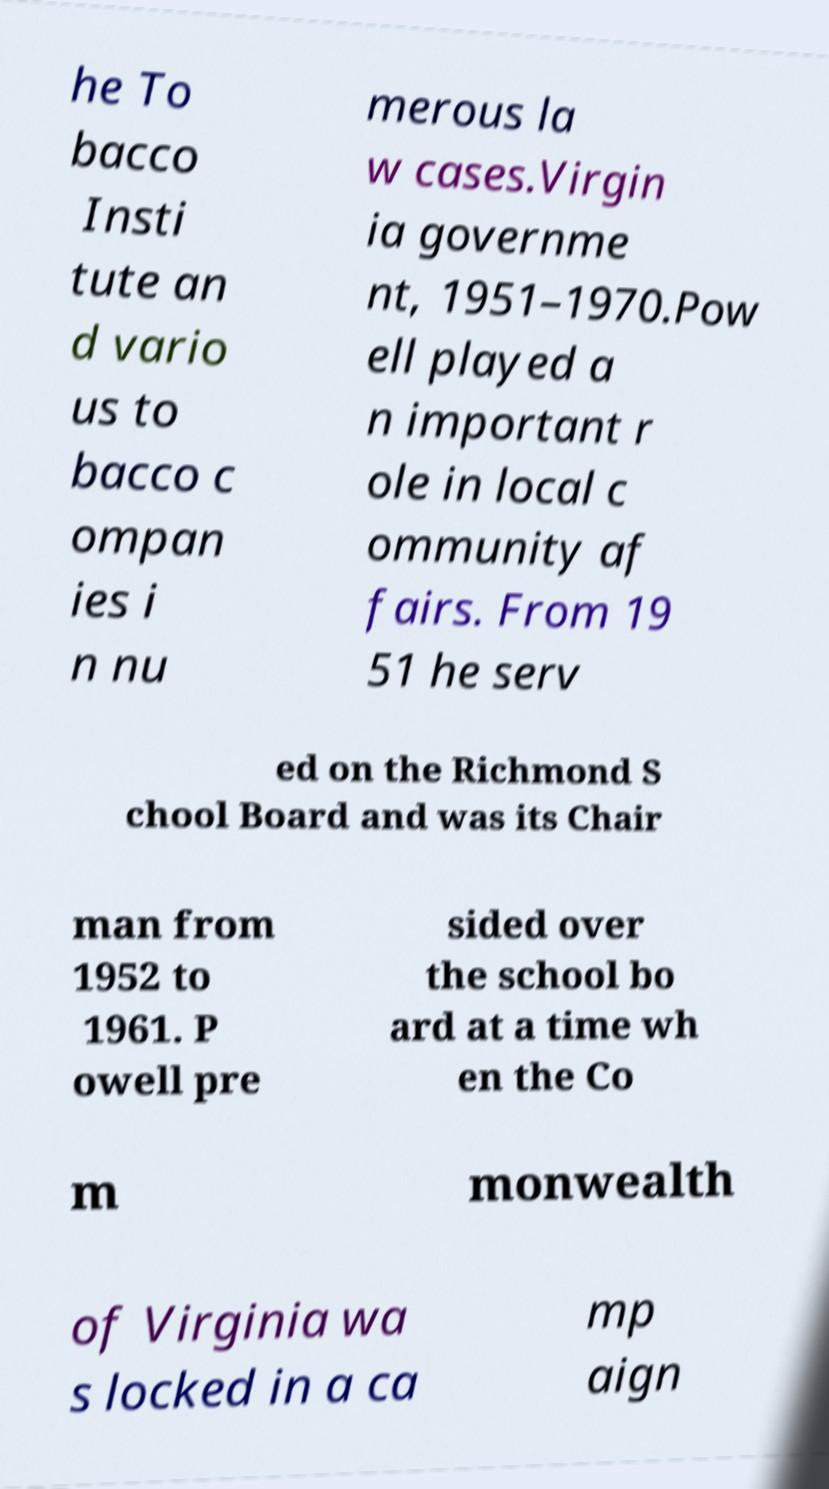Can you accurately transcribe the text from the provided image for me? he To bacco Insti tute an d vario us to bacco c ompan ies i n nu merous la w cases.Virgin ia governme nt, 1951–1970.Pow ell played a n important r ole in local c ommunity af fairs. From 19 51 he serv ed on the Richmond S chool Board and was its Chair man from 1952 to 1961. P owell pre sided over the school bo ard at a time wh en the Co m monwealth of Virginia wa s locked in a ca mp aign 